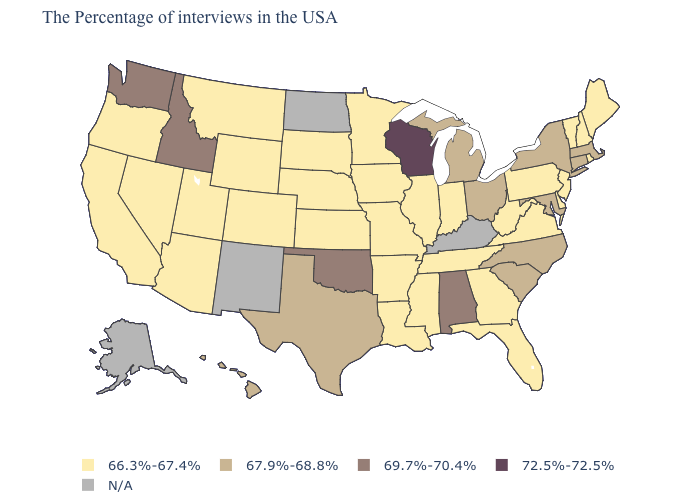What is the highest value in states that border Arkansas?
Concise answer only. 69.7%-70.4%. What is the lowest value in the USA?
Quick response, please. 66.3%-67.4%. Name the states that have a value in the range 67.9%-68.8%?
Be succinct. Massachusetts, Connecticut, New York, Maryland, North Carolina, South Carolina, Ohio, Michigan, Texas, Hawaii. Name the states that have a value in the range N/A?
Answer briefly. Kentucky, North Dakota, New Mexico, Alaska. What is the value of Utah?
Be succinct. 66.3%-67.4%. Name the states that have a value in the range 67.9%-68.8%?
Keep it brief. Massachusetts, Connecticut, New York, Maryland, North Carolina, South Carolina, Ohio, Michigan, Texas, Hawaii. How many symbols are there in the legend?
Concise answer only. 5. Name the states that have a value in the range 67.9%-68.8%?
Keep it brief. Massachusetts, Connecticut, New York, Maryland, North Carolina, South Carolina, Ohio, Michigan, Texas, Hawaii. What is the highest value in the South ?
Write a very short answer. 69.7%-70.4%. Is the legend a continuous bar?
Be succinct. No. Does the map have missing data?
Keep it brief. Yes. What is the highest value in the USA?
Write a very short answer. 72.5%-72.5%. What is the value of Kentucky?
Concise answer only. N/A. How many symbols are there in the legend?
Keep it brief. 5. 